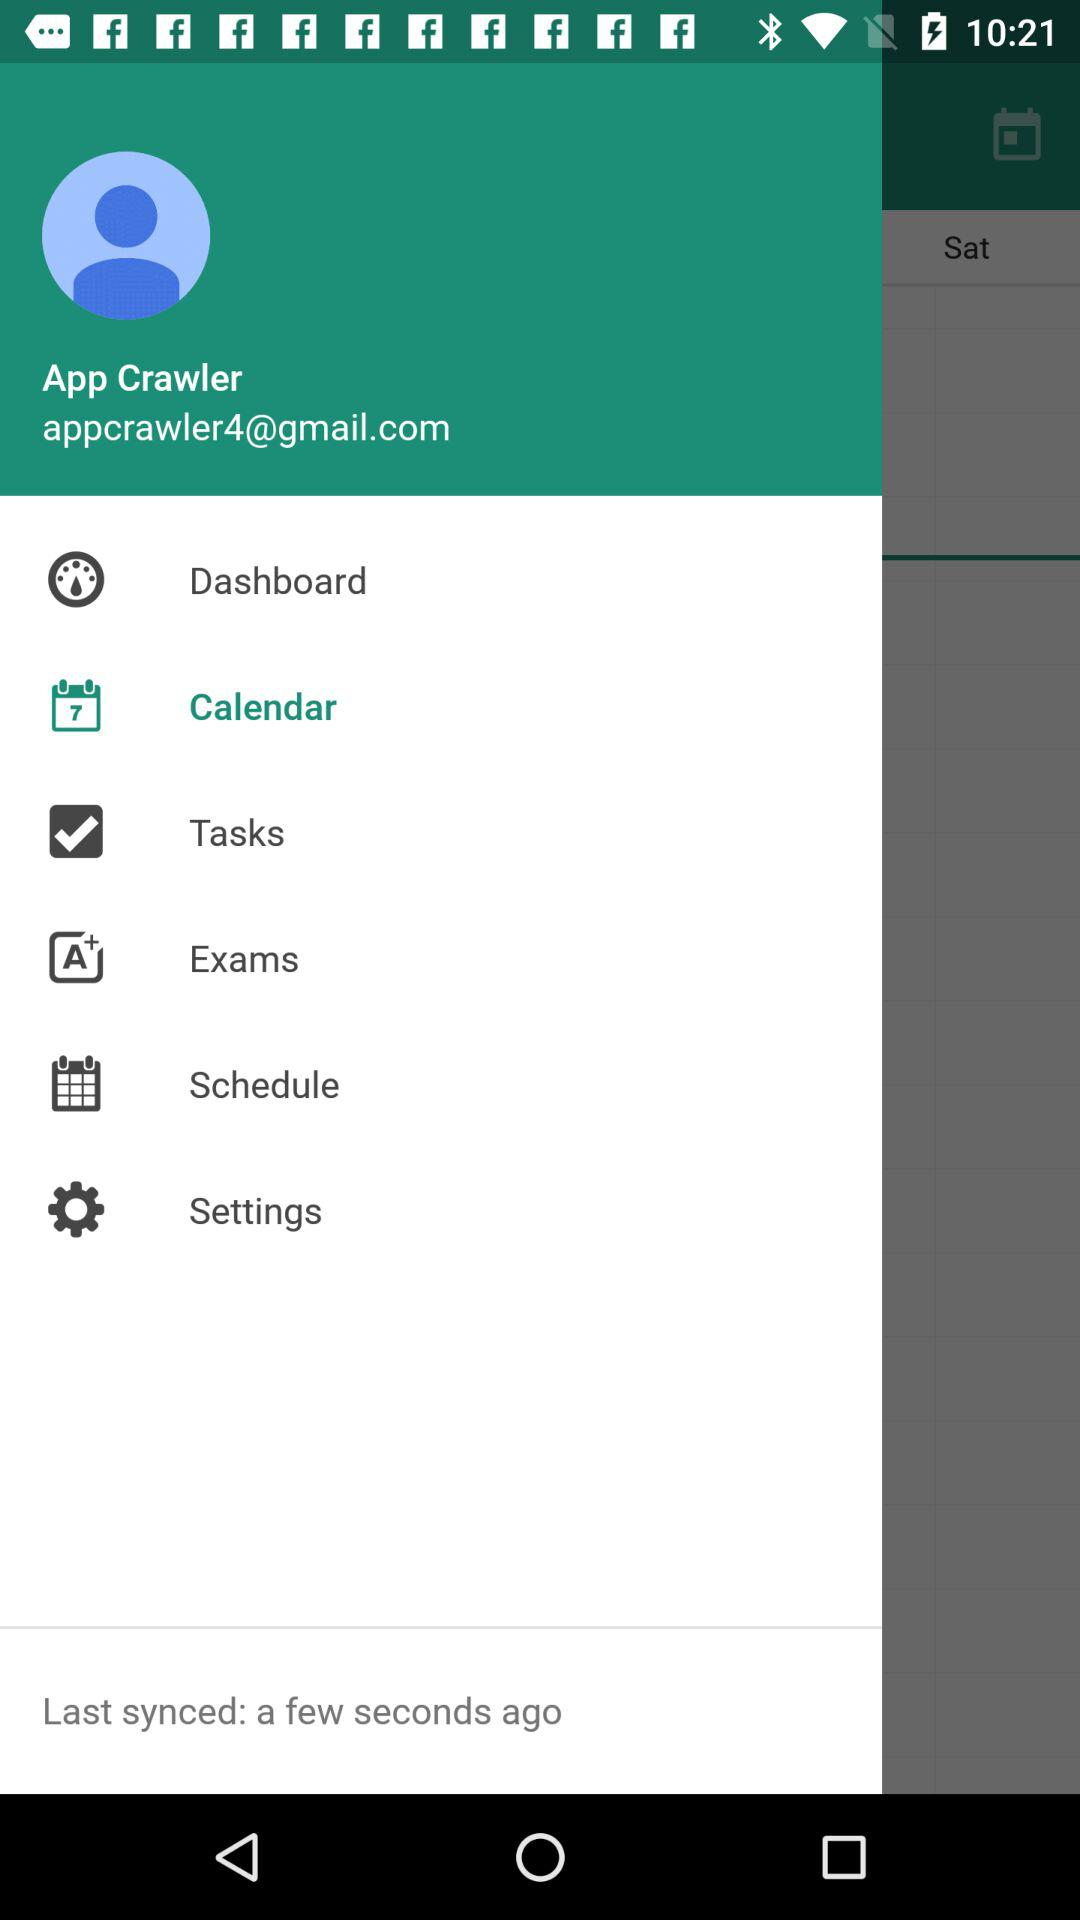What is the user name? The user name is App Crawler. 